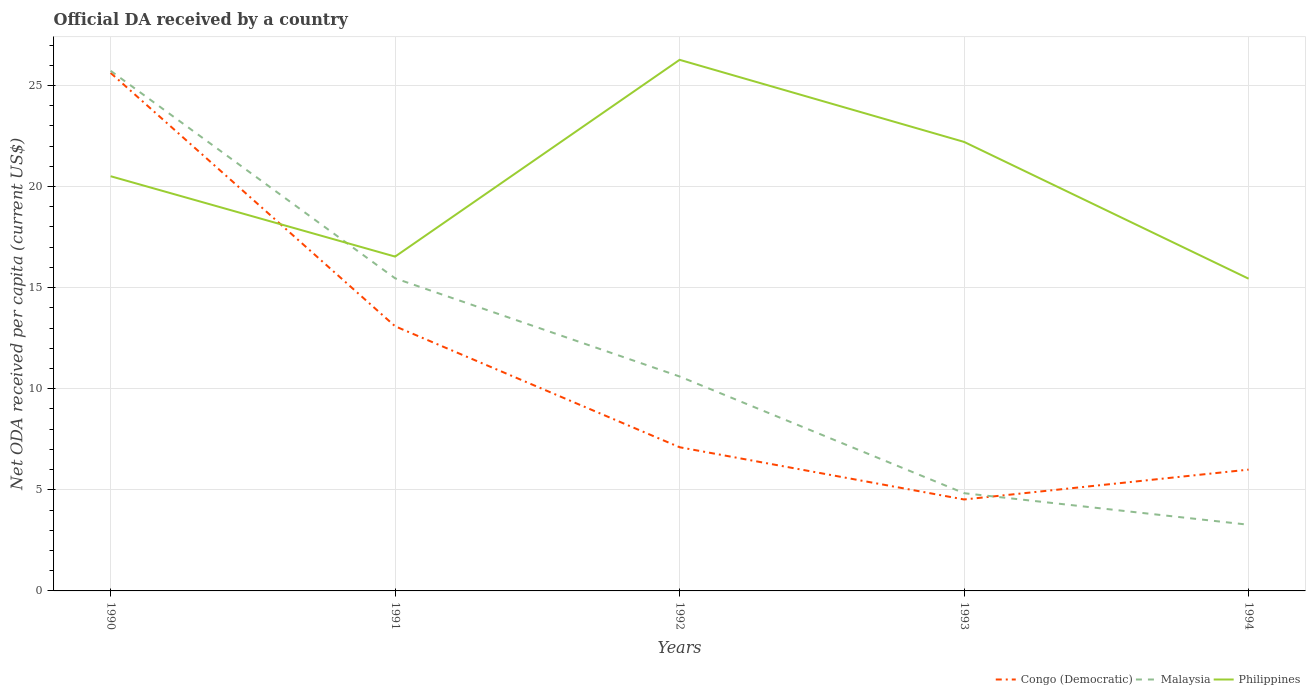Does the line corresponding to Congo (Democratic) intersect with the line corresponding to Philippines?
Provide a short and direct response. Yes. Is the number of lines equal to the number of legend labels?
Your response must be concise. Yes. Across all years, what is the maximum ODA received in in Malaysia?
Provide a succinct answer. 3.27. In which year was the ODA received in in Congo (Democratic) maximum?
Your response must be concise. 1993. What is the total ODA received in in Philippines in the graph?
Give a very brief answer. 1.09. What is the difference between the highest and the second highest ODA received in in Malaysia?
Offer a very short reply. 22.45. Is the ODA received in in Congo (Democratic) strictly greater than the ODA received in in Malaysia over the years?
Give a very brief answer. No. How many lines are there?
Ensure brevity in your answer.  3. What is the difference between two consecutive major ticks on the Y-axis?
Ensure brevity in your answer.  5. Where does the legend appear in the graph?
Provide a short and direct response. Bottom right. What is the title of the graph?
Offer a very short reply. Official DA received by a country. Does "Cabo Verde" appear as one of the legend labels in the graph?
Offer a very short reply. No. What is the label or title of the Y-axis?
Ensure brevity in your answer.  Net ODA received per capita (current US$). What is the Net ODA received per capita (current US$) of Congo (Democratic) in 1990?
Your response must be concise. 25.62. What is the Net ODA received per capita (current US$) of Malaysia in 1990?
Keep it short and to the point. 25.73. What is the Net ODA received per capita (current US$) in Philippines in 1990?
Your response must be concise. 20.51. What is the Net ODA received per capita (current US$) of Congo (Democratic) in 1991?
Provide a short and direct response. 13.09. What is the Net ODA received per capita (current US$) of Malaysia in 1991?
Your answer should be very brief. 15.46. What is the Net ODA received per capita (current US$) in Philippines in 1991?
Offer a very short reply. 16.54. What is the Net ODA received per capita (current US$) of Congo (Democratic) in 1992?
Provide a short and direct response. 7.11. What is the Net ODA received per capita (current US$) of Malaysia in 1992?
Provide a succinct answer. 10.61. What is the Net ODA received per capita (current US$) of Philippines in 1992?
Offer a terse response. 26.27. What is the Net ODA received per capita (current US$) of Congo (Democratic) in 1993?
Give a very brief answer. 4.52. What is the Net ODA received per capita (current US$) in Malaysia in 1993?
Provide a succinct answer. 4.83. What is the Net ODA received per capita (current US$) of Philippines in 1993?
Provide a short and direct response. 22.21. What is the Net ODA received per capita (current US$) in Congo (Democratic) in 1994?
Your answer should be compact. 6. What is the Net ODA received per capita (current US$) in Malaysia in 1994?
Your answer should be compact. 3.27. What is the Net ODA received per capita (current US$) of Philippines in 1994?
Make the answer very short. 15.44. Across all years, what is the maximum Net ODA received per capita (current US$) of Congo (Democratic)?
Provide a short and direct response. 25.62. Across all years, what is the maximum Net ODA received per capita (current US$) of Malaysia?
Your response must be concise. 25.73. Across all years, what is the maximum Net ODA received per capita (current US$) of Philippines?
Provide a short and direct response. 26.27. Across all years, what is the minimum Net ODA received per capita (current US$) in Congo (Democratic)?
Provide a short and direct response. 4.52. Across all years, what is the minimum Net ODA received per capita (current US$) of Malaysia?
Provide a short and direct response. 3.27. Across all years, what is the minimum Net ODA received per capita (current US$) of Philippines?
Make the answer very short. 15.44. What is the total Net ODA received per capita (current US$) of Congo (Democratic) in the graph?
Ensure brevity in your answer.  56.34. What is the total Net ODA received per capita (current US$) in Malaysia in the graph?
Give a very brief answer. 59.9. What is the total Net ODA received per capita (current US$) of Philippines in the graph?
Provide a succinct answer. 100.97. What is the difference between the Net ODA received per capita (current US$) of Congo (Democratic) in 1990 and that in 1991?
Offer a terse response. 12.53. What is the difference between the Net ODA received per capita (current US$) of Malaysia in 1990 and that in 1991?
Your answer should be very brief. 10.26. What is the difference between the Net ODA received per capita (current US$) in Philippines in 1990 and that in 1991?
Your response must be concise. 3.97. What is the difference between the Net ODA received per capita (current US$) of Congo (Democratic) in 1990 and that in 1992?
Provide a short and direct response. 18.51. What is the difference between the Net ODA received per capita (current US$) of Malaysia in 1990 and that in 1992?
Your response must be concise. 15.12. What is the difference between the Net ODA received per capita (current US$) of Philippines in 1990 and that in 1992?
Keep it short and to the point. -5.76. What is the difference between the Net ODA received per capita (current US$) of Congo (Democratic) in 1990 and that in 1993?
Provide a succinct answer. 21.1. What is the difference between the Net ODA received per capita (current US$) in Malaysia in 1990 and that in 1993?
Provide a succinct answer. 20.89. What is the difference between the Net ODA received per capita (current US$) of Philippines in 1990 and that in 1993?
Provide a succinct answer. -1.7. What is the difference between the Net ODA received per capita (current US$) in Congo (Democratic) in 1990 and that in 1994?
Ensure brevity in your answer.  19.62. What is the difference between the Net ODA received per capita (current US$) in Malaysia in 1990 and that in 1994?
Give a very brief answer. 22.45. What is the difference between the Net ODA received per capita (current US$) of Philippines in 1990 and that in 1994?
Offer a very short reply. 5.07. What is the difference between the Net ODA received per capita (current US$) in Congo (Democratic) in 1991 and that in 1992?
Make the answer very short. 5.98. What is the difference between the Net ODA received per capita (current US$) in Malaysia in 1991 and that in 1992?
Offer a terse response. 4.86. What is the difference between the Net ODA received per capita (current US$) of Philippines in 1991 and that in 1992?
Offer a very short reply. -9.73. What is the difference between the Net ODA received per capita (current US$) of Congo (Democratic) in 1991 and that in 1993?
Keep it short and to the point. 8.57. What is the difference between the Net ODA received per capita (current US$) of Malaysia in 1991 and that in 1993?
Keep it short and to the point. 10.63. What is the difference between the Net ODA received per capita (current US$) of Philippines in 1991 and that in 1993?
Your response must be concise. -5.67. What is the difference between the Net ODA received per capita (current US$) in Congo (Democratic) in 1991 and that in 1994?
Make the answer very short. 7.09. What is the difference between the Net ODA received per capita (current US$) of Malaysia in 1991 and that in 1994?
Keep it short and to the point. 12.19. What is the difference between the Net ODA received per capita (current US$) of Philippines in 1991 and that in 1994?
Provide a short and direct response. 1.09. What is the difference between the Net ODA received per capita (current US$) in Congo (Democratic) in 1992 and that in 1993?
Ensure brevity in your answer.  2.58. What is the difference between the Net ODA received per capita (current US$) in Malaysia in 1992 and that in 1993?
Make the answer very short. 5.77. What is the difference between the Net ODA received per capita (current US$) in Philippines in 1992 and that in 1993?
Ensure brevity in your answer.  4.06. What is the difference between the Net ODA received per capita (current US$) of Congo (Democratic) in 1992 and that in 1994?
Your answer should be compact. 1.11. What is the difference between the Net ODA received per capita (current US$) in Malaysia in 1992 and that in 1994?
Your answer should be very brief. 7.33. What is the difference between the Net ODA received per capita (current US$) in Philippines in 1992 and that in 1994?
Make the answer very short. 10.83. What is the difference between the Net ODA received per capita (current US$) of Congo (Democratic) in 1993 and that in 1994?
Ensure brevity in your answer.  -1.48. What is the difference between the Net ODA received per capita (current US$) in Malaysia in 1993 and that in 1994?
Make the answer very short. 1.56. What is the difference between the Net ODA received per capita (current US$) of Philippines in 1993 and that in 1994?
Provide a succinct answer. 6.77. What is the difference between the Net ODA received per capita (current US$) in Congo (Democratic) in 1990 and the Net ODA received per capita (current US$) in Malaysia in 1991?
Provide a short and direct response. 10.16. What is the difference between the Net ODA received per capita (current US$) of Congo (Democratic) in 1990 and the Net ODA received per capita (current US$) of Philippines in 1991?
Offer a terse response. 9.08. What is the difference between the Net ODA received per capita (current US$) of Malaysia in 1990 and the Net ODA received per capita (current US$) of Philippines in 1991?
Your answer should be compact. 9.19. What is the difference between the Net ODA received per capita (current US$) of Congo (Democratic) in 1990 and the Net ODA received per capita (current US$) of Malaysia in 1992?
Provide a succinct answer. 15.01. What is the difference between the Net ODA received per capita (current US$) in Congo (Democratic) in 1990 and the Net ODA received per capita (current US$) in Philippines in 1992?
Offer a terse response. -0.65. What is the difference between the Net ODA received per capita (current US$) of Malaysia in 1990 and the Net ODA received per capita (current US$) of Philippines in 1992?
Offer a terse response. -0.54. What is the difference between the Net ODA received per capita (current US$) in Congo (Democratic) in 1990 and the Net ODA received per capita (current US$) in Malaysia in 1993?
Ensure brevity in your answer.  20.79. What is the difference between the Net ODA received per capita (current US$) of Congo (Democratic) in 1990 and the Net ODA received per capita (current US$) of Philippines in 1993?
Keep it short and to the point. 3.41. What is the difference between the Net ODA received per capita (current US$) of Malaysia in 1990 and the Net ODA received per capita (current US$) of Philippines in 1993?
Give a very brief answer. 3.52. What is the difference between the Net ODA received per capita (current US$) in Congo (Democratic) in 1990 and the Net ODA received per capita (current US$) in Malaysia in 1994?
Offer a very short reply. 22.35. What is the difference between the Net ODA received per capita (current US$) of Congo (Democratic) in 1990 and the Net ODA received per capita (current US$) of Philippines in 1994?
Offer a very short reply. 10.18. What is the difference between the Net ODA received per capita (current US$) in Malaysia in 1990 and the Net ODA received per capita (current US$) in Philippines in 1994?
Make the answer very short. 10.28. What is the difference between the Net ODA received per capita (current US$) of Congo (Democratic) in 1991 and the Net ODA received per capita (current US$) of Malaysia in 1992?
Provide a short and direct response. 2.48. What is the difference between the Net ODA received per capita (current US$) in Congo (Democratic) in 1991 and the Net ODA received per capita (current US$) in Philippines in 1992?
Offer a very short reply. -13.18. What is the difference between the Net ODA received per capita (current US$) of Malaysia in 1991 and the Net ODA received per capita (current US$) of Philippines in 1992?
Provide a short and direct response. -10.81. What is the difference between the Net ODA received per capita (current US$) in Congo (Democratic) in 1991 and the Net ODA received per capita (current US$) in Malaysia in 1993?
Offer a terse response. 8.26. What is the difference between the Net ODA received per capita (current US$) in Congo (Democratic) in 1991 and the Net ODA received per capita (current US$) in Philippines in 1993?
Offer a very short reply. -9.12. What is the difference between the Net ODA received per capita (current US$) in Malaysia in 1991 and the Net ODA received per capita (current US$) in Philippines in 1993?
Keep it short and to the point. -6.75. What is the difference between the Net ODA received per capita (current US$) of Congo (Democratic) in 1991 and the Net ODA received per capita (current US$) of Malaysia in 1994?
Your answer should be compact. 9.82. What is the difference between the Net ODA received per capita (current US$) in Congo (Democratic) in 1991 and the Net ODA received per capita (current US$) in Philippines in 1994?
Offer a terse response. -2.35. What is the difference between the Net ODA received per capita (current US$) of Malaysia in 1991 and the Net ODA received per capita (current US$) of Philippines in 1994?
Offer a terse response. 0.02. What is the difference between the Net ODA received per capita (current US$) of Congo (Democratic) in 1992 and the Net ODA received per capita (current US$) of Malaysia in 1993?
Offer a terse response. 2.27. What is the difference between the Net ODA received per capita (current US$) of Congo (Democratic) in 1992 and the Net ODA received per capita (current US$) of Philippines in 1993?
Make the answer very short. -15.1. What is the difference between the Net ODA received per capita (current US$) of Malaysia in 1992 and the Net ODA received per capita (current US$) of Philippines in 1993?
Provide a succinct answer. -11.6. What is the difference between the Net ODA received per capita (current US$) of Congo (Democratic) in 1992 and the Net ODA received per capita (current US$) of Malaysia in 1994?
Offer a terse response. 3.83. What is the difference between the Net ODA received per capita (current US$) of Congo (Democratic) in 1992 and the Net ODA received per capita (current US$) of Philippines in 1994?
Make the answer very short. -8.34. What is the difference between the Net ODA received per capita (current US$) in Malaysia in 1992 and the Net ODA received per capita (current US$) in Philippines in 1994?
Your answer should be very brief. -4.84. What is the difference between the Net ODA received per capita (current US$) of Congo (Democratic) in 1993 and the Net ODA received per capita (current US$) of Malaysia in 1994?
Give a very brief answer. 1.25. What is the difference between the Net ODA received per capita (current US$) in Congo (Democratic) in 1993 and the Net ODA received per capita (current US$) in Philippines in 1994?
Ensure brevity in your answer.  -10.92. What is the difference between the Net ODA received per capita (current US$) of Malaysia in 1993 and the Net ODA received per capita (current US$) of Philippines in 1994?
Ensure brevity in your answer.  -10.61. What is the average Net ODA received per capita (current US$) of Congo (Democratic) per year?
Offer a very short reply. 11.27. What is the average Net ODA received per capita (current US$) in Malaysia per year?
Offer a terse response. 11.98. What is the average Net ODA received per capita (current US$) in Philippines per year?
Provide a short and direct response. 20.19. In the year 1990, what is the difference between the Net ODA received per capita (current US$) in Congo (Democratic) and Net ODA received per capita (current US$) in Malaysia?
Your answer should be very brief. -0.1. In the year 1990, what is the difference between the Net ODA received per capita (current US$) in Congo (Democratic) and Net ODA received per capita (current US$) in Philippines?
Keep it short and to the point. 5.11. In the year 1990, what is the difference between the Net ODA received per capita (current US$) in Malaysia and Net ODA received per capita (current US$) in Philippines?
Make the answer very short. 5.21. In the year 1991, what is the difference between the Net ODA received per capita (current US$) in Congo (Democratic) and Net ODA received per capita (current US$) in Malaysia?
Provide a short and direct response. -2.37. In the year 1991, what is the difference between the Net ODA received per capita (current US$) in Congo (Democratic) and Net ODA received per capita (current US$) in Philippines?
Provide a short and direct response. -3.45. In the year 1991, what is the difference between the Net ODA received per capita (current US$) in Malaysia and Net ODA received per capita (current US$) in Philippines?
Provide a succinct answer. -1.07. In the year 1992, what is the difference between the Net ODA received per capita (current US$) of Congo (Democratic) and Net ODA received per capita (current US$) of Philippines?
Your answer should be very brief. -19.16. In the year 1992, what is the difference between the Net ODA received per capita (current US$) in Malaysia and Net ODA received per capita (current US$) in Philippines?
Provide a succinct answer. -15.66. In the year 1993, what is the difference between the Net ODA received per capita (current US$) in Congo (Democratic) and Net ODA received per capita (current US$) in Malaysia?
Provide a succinct answer. -0.31. In the year 1993, what is the difference between the Net ODA received per capita (current US$) in Congo (Democratic) and Net ODA received per capita (current US$) in Philippines?
Ensure brevity in your answer.  -17.69. In the year 1993, what is the difference between the Net ODA received per capita (current US$) in Malaysia and Net ODA received per capita (current US$) in Philippines?
Keep it short and to the point. -17.38. In the year 1994, what is the difference between the Net ODA received per capita (current US$) of Congo (Democratic) and Net ODA received per capita (current US$) of Malaysia?
Offer a very short reply. 2.73. In the year 1994, what is the difference between the Net ODA received per capita (current US$) in Congo (Democratic) and Net ODA received per capita (current US$) in Philippines?
Keep it short and to the point. -9.44. In the year 1994, what is the difference between the Net ODA received per capita (current US$) in Malaysia and Net ODA received per capita (current US$) in Philippines?
Ensure brevity in your answer.  -12.17. What is the ratio of the Net ODA received per capita (current US$) of Congo (Democratic) in 1990 to that in 1991?
Provide a short and direct response. 1.96. What is the ratio of the Net ODA received per capita (current US$) in Malaysia in 1990 to that in 1991?
Provide a short and direct response. 1.66. What is the ratio of the Net ODA received per capita (current US$) in Philippines in 1990 to that in 1991?
Provide a succinct answer. 1.24. What is the ratio of the Net ODA received per capita (current US$) in Congo (Democratic) in 1990 to that in 1992?
Your answer should be very brief. 3.61. What is the ratio of the Net ODA received per capita (current US$) in Malaysia in 1990 to that in 1992?
Give a very brief answer. 2.43. What is the ratio of the Net ODA received per capita (current US$) in Philippines in 1990 to that in 1992?
Give a very brief answer. 0.78. What is the ratio of the Net ODA received per capita (current US$) in Congo (Democratic) in 1990 to that in 1993?
Give a very brief answer. 5.66. What is the ratio of the Net ODA received per capita (current US$) of Malaysia in 1990 to that in 1993?
Provide a short and direct response. 5.32. What is the ratio of the Net ODA received per capita (current US$) of Philippines in 1990 to that in 1993?
Provide a succinct answer. 0.92. What is the ratio of the Net ODA received per capita (current US$) of Congo (Democratic) in 1990 to that in 1994?
Ensure brevity in your answer.  4.27. What is the ratio of the Net ODA received per capita (current US$) in Malaysia in 1990 to that in 1994?
Keep it short and to the point. 7.86. What is the ratio of the Net ODA received per capita (current US$) in Philippines in 1990 to that in 1994?
Ensure brevity in your answer.  1.33. What is the ratio of the Net ODA received per capita (current US$) of Congo (Democratic) in 1991 to that in 1992?
Your response must be concise. 1.84. What is the ratio of the Net ODA received per capita (current US$) of Malaysia in 1991 to that in 1992?
Your answer should be compact. 1.46. What is the ratio of the Net ODA received per capita (current US$) in Philippines in 1991 to that in 1992?
Provide a short and direct response. 0.63. What is the ratio of the Net ODA received per capita (current US$) of Congo (Democratic) in 1991 to that in 1993?
Your answer should be compact. 2.89. What is the ratio of the Net ODA received per capita (current US$) of Malaysia in 1991 to that in 1993?
Give a very brief answer. 3.2. What is the ratio of the Net ODA received per capita (current US$) of Philippines in 1991 to that in 1993?
Provide a short and direct response. 0.74. What is the ratio of the Net ODA received per capita (current US$) of Congo (Democratic) in 1991 to that in 1994?
Your response must be concise. 2.18. What is the ratio of the Net ODA received per capita (current US$) in Malaysia in 1991 to that in 1994?
Provide a short and direct response. 4.72. What is the ratio of the Net ODA received per capita (current US$) in Philippines in 1991 to that in 1994?
Offer a terse response. 1.07. What is the ratio of the Net ODA received per capita (current US$) in Congo (Democratic) in 1992 to that in 1993?
Offer a terse response. 1.57. What is the ratio of the Net ODA received per capita (current US$) in Malaysia in 1992 to that in 1993?
Make the answer very short. 2.19. What is the ratio of the Net ODA received per capita (current US$) of Philippines in 1992 to that in 1993?
Provide a short and direct response. 1.18. What is the ratio of the Net ODA received per capita (current US$) in Congo (Democratic) in 1992 to that in 1994?
Give a very brief answer. 1.18. What is the ratio of the Net ODA received per capita (current US$) of Malaysia in 1992 to that in 1994?
Your answer should be very brief. 3.24. What is the ratio of the Net ODA received per capita (current US$) of Philippines in 1992 to that in 1994?
Keep it short and to the point. 1.7. What is the ratio of the Net ODA received per capita (current US$) of Congo (Democratic) in 1993 to that in 1994?
Give a very brief answer. 0.75. What is the ratio of the Net ODA received per capita (current US$) in Malaysia in 1993 to that in 1994?
Make the answer very short. 1.48. What is the ratio of the Net ODA received per capita (current US$) of Philippines in 1993 to that in 1994?
Make the answer very short. 1.44. What is the difference between the highest and the second highest Net ODA received per capita (current US$) in Congo (Democratic)?
Your response must be concise. 12.53. What is the difference between the highest and the second highest Net ODA received per capita (current US$) in Malaysia?
Your answer should be very brief. 10.26. What is the difference between the highest and the second highest Net ODA received per capita (current US$) in Philippines?
Make the answer very short. 4.06. What is the difference between the highest and the lowest Net ODA received per capita (current US$) in Congo (Democratic)?
Offer a very short reply. 21.1. What is the difference between the highest and the lowest Net ODA received per capita (current US$) in Malaysia?
Provide a short and direct response. 22.45. What is the difference between the highest and the lowest Net ODA received per capita (current US$) of Philippines?
Provide a succinct answer. 10.83. 